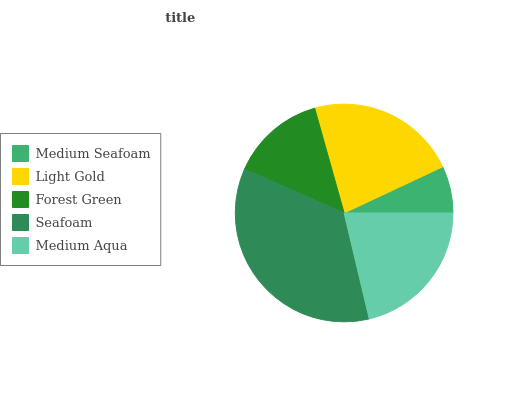Is Medium Seafoam the minimum?
Answer yes or no. Yes. Is Seafoam the maximum?
Answer yes or no. Yes. Is Light Gold the minimum?
Answer yes or no. No. Is Light Gold the maximum?
Answer yes or no. No. Is Light Gold greater than Medium Seafoam?
Answer yes or no. Yes. Is Medium Seafoam less than Light Gold?
Answer yes or no. Yes. Is Medium Seafoam greater than Light Gold?
Answer yes or no. No. Is Light Gold less than Medium Seafoam?
Answer yes or no. No. Is Medium Aqua the high median?
Answer yes or no. Yes. Is Medium Aqua the low median?
Answer yes or no. Yes. Is Seafoam the high median?
Answer yes or no. No. Is Medium Seafoam the low median?
Answer yes or no. No. 